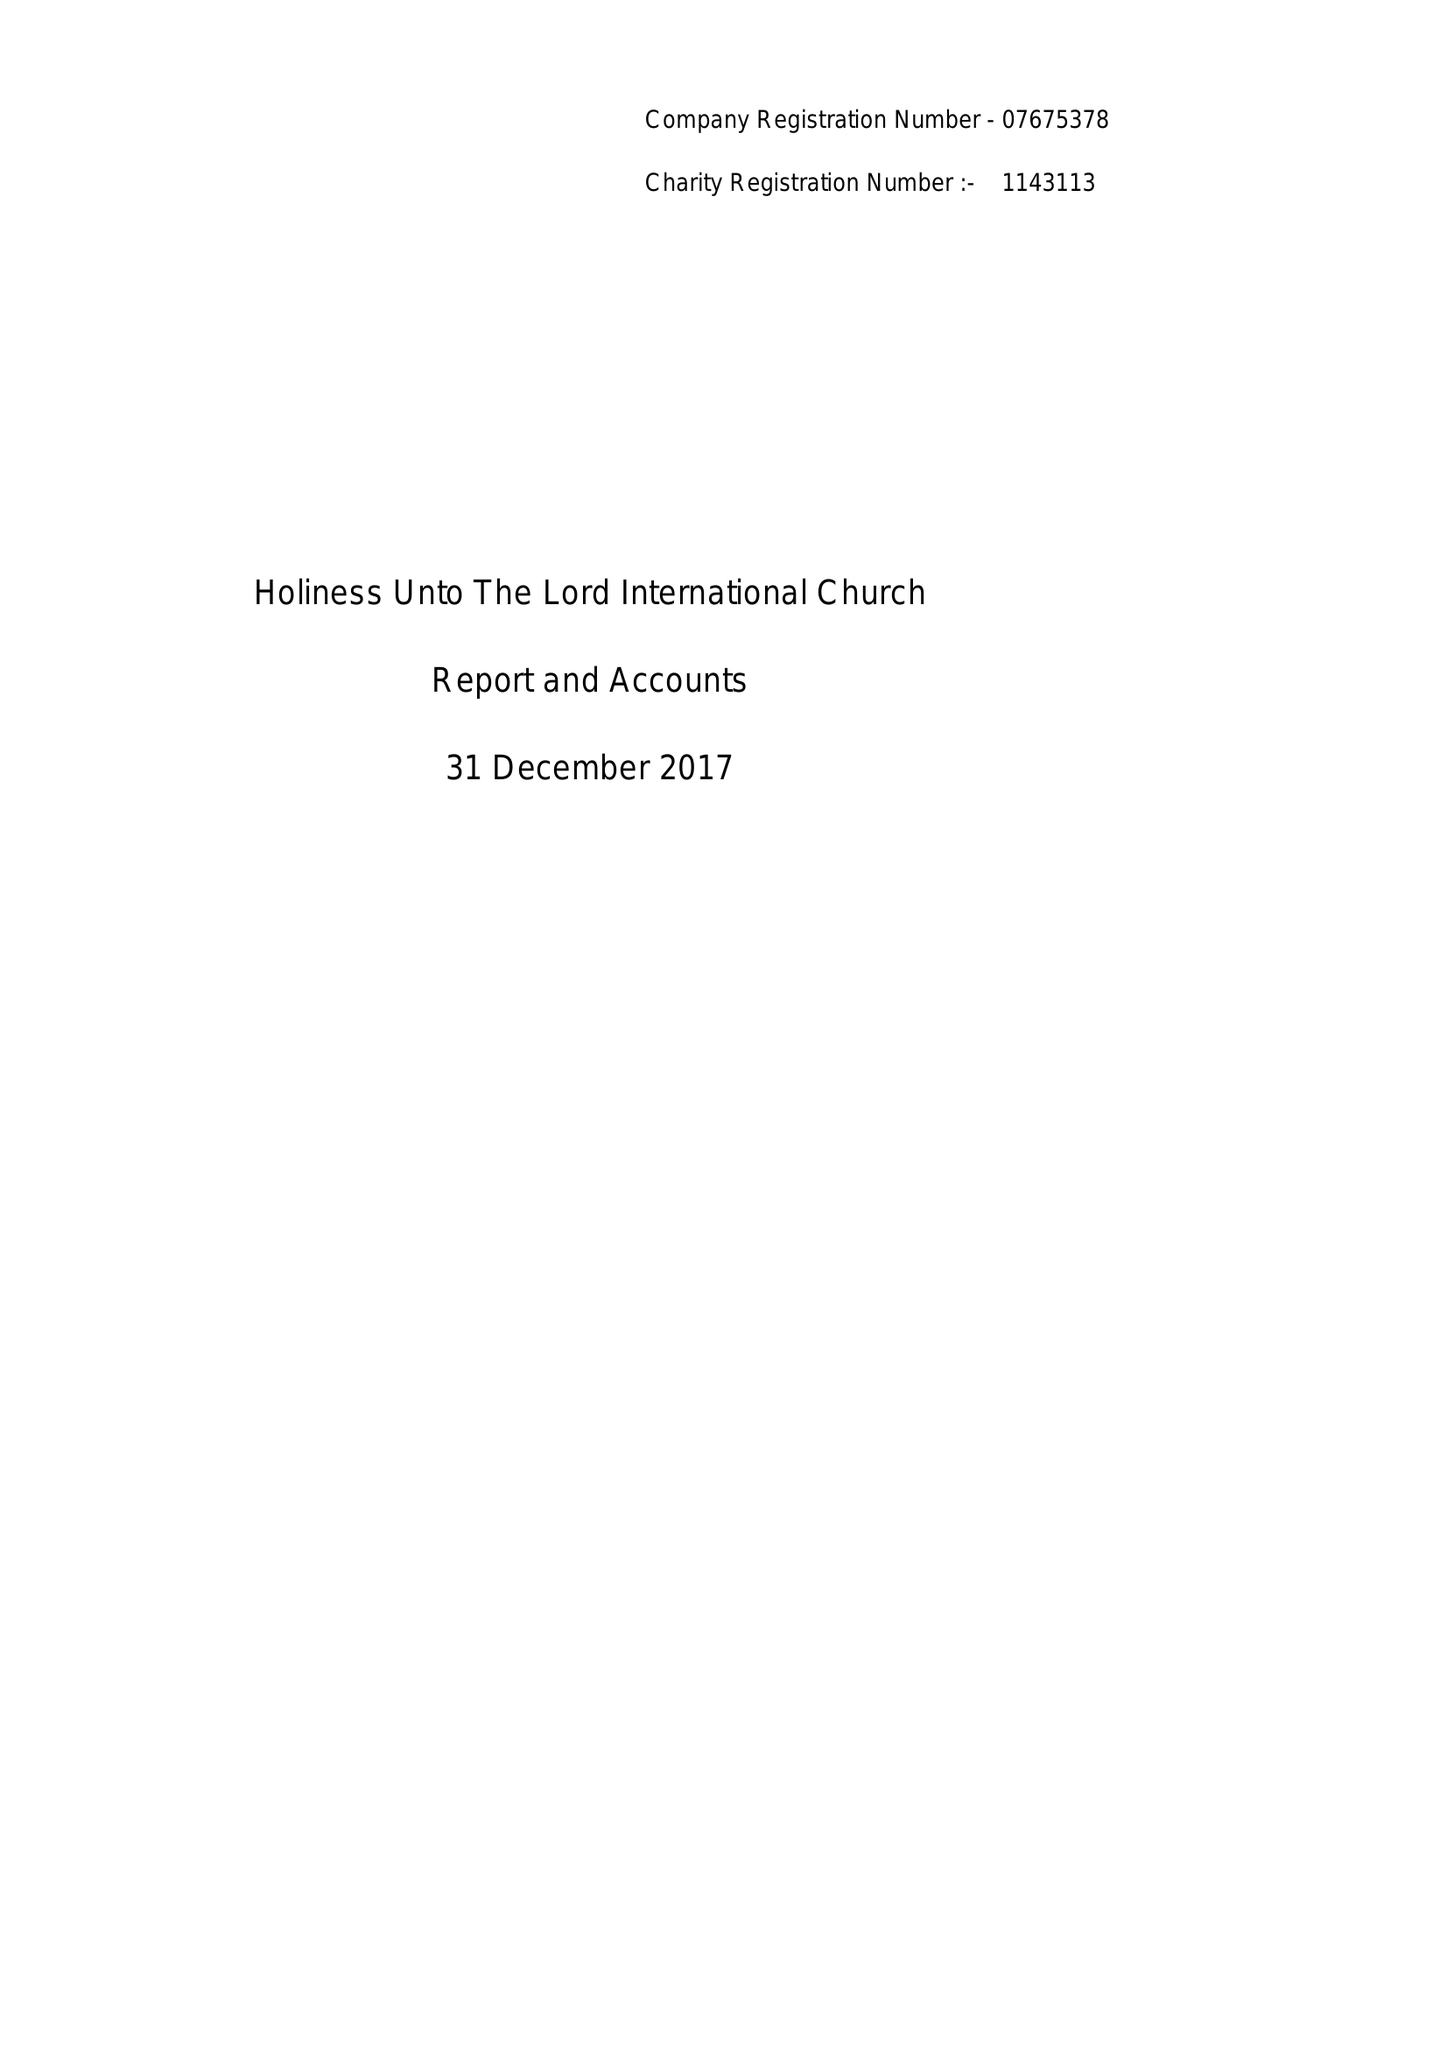What is the value for the income_annually_in_british_pounds?
Answer the question using a single word or phrase. 105764.00 